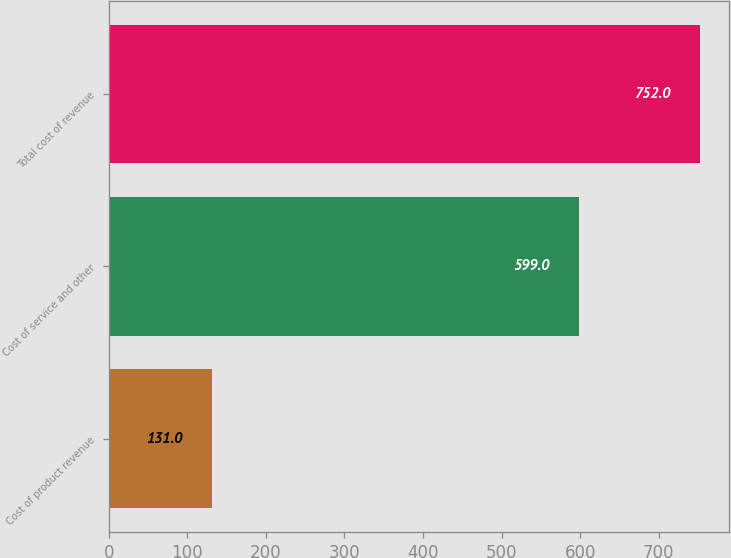Convert chart to OTSL. <chart><loc_0><loc_0><loc_500><loc_500><bar_chart><fcel>Cost of product revenue<fcel>Cost of service and other<fcel>Total cost of revenue<nl><fcel>131<fcel>599<fcel>752<nl></chart> 